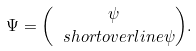Convert formula to latex. <formula><loc_0><loc_0><loc_500><loc_500>\Psi = \binom { \psi } { \ s h o r t o v e r l i n e { \psi } } .</formula> 